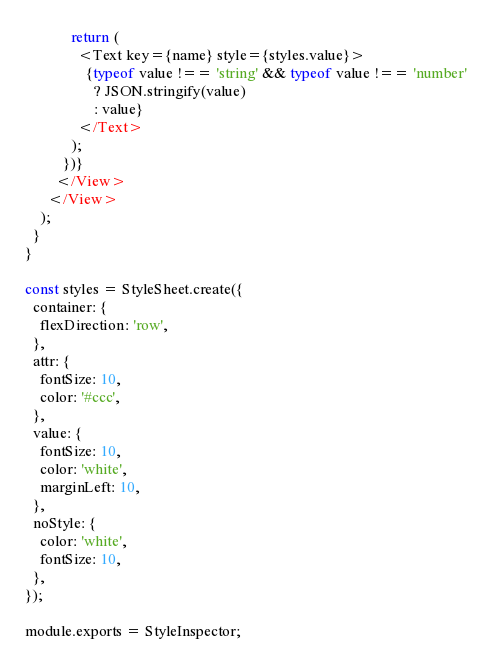Convert code to text. <code><loc_0><loc_0><loc_500><loc_500><_JavaScript_>            return (
              <Text key={name} style={styles.value}>
                {typeof value !== 'string' && typeof value !== 'number'
                  ? JSON.stringify(value)
                  : value}
              </Text>
            );
          })}
        </View>
      </View>
    );
  }
}

const styles = StyleSheet.create({
  container: {
    flexDirection: 'row',
  },
  attr: {
    fontSize: 10,
    color: '#ccc',
  },
  value: {
    fontSize: 10,
    color: 'white',
    marginLeft: 10,
  },
  noStyle: {
    color: 'white',
    fontSize: 10,
  },
});

module.exports = StyleInspector;
</code> 